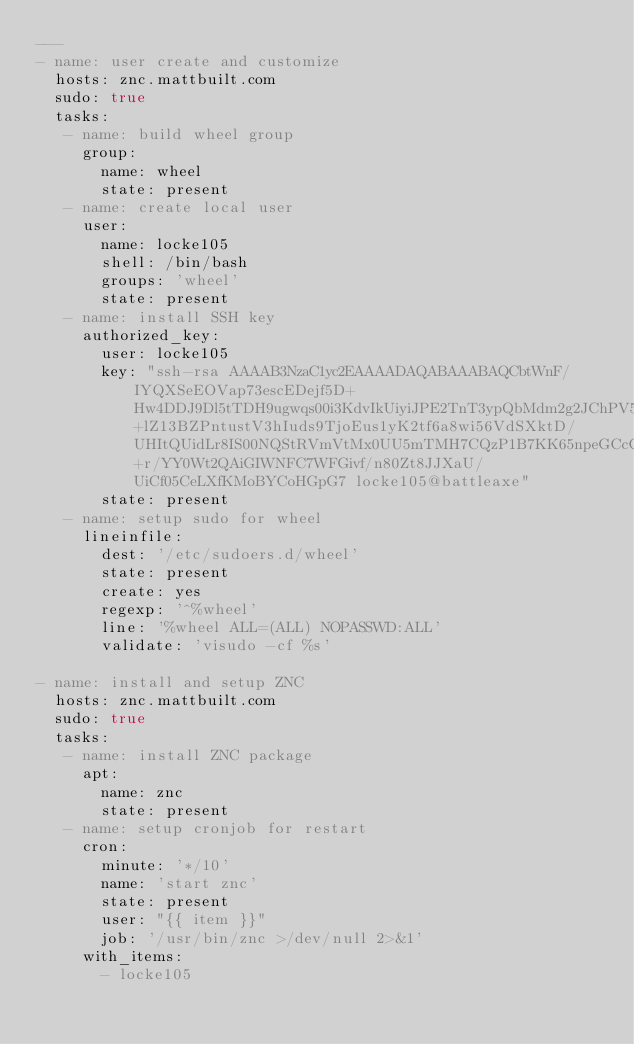<code> <loc_0><loc_0><loc_500><loc_500><_YAML_>---
- name: user create and customize
  hosts: znc.mattbuilt.com
  sudo: true
  tasks:
   - name: build wheel group
     group:
       name: wheel
       state: present
   - name: create local user
     user:
       name: locke105
       shell: /bin/bash
       groups: 'wheel'
       state: present
   - name: install SSH key
     authorized_key:
       user: locke105
       key: "ssh-rsa AAAAB3NzaC1yc2EAAAADAQABAAABAQCbtWnF/IYQXSeEOVap73escEDejf5D+Hw4DDJ9Dl5tTDH9ugwqs00i3KdvIkUiyiJPE2TnT3ypQbMdm2g2JChPV5N8P2HDvKDpfDQHBMlBYMUDtzA+lZ13BZPntustV3hIuds9TjoEus1yK2tf6a8wi56VdSXktD/UHItQUidLr8IS00NQStRVmVtMx0UU5mTMH7CQzP1B7KK65npeGCcCZOeQ7cUcAEcBOlfPjlabm1OS1bx90ZJHt9UmBQFP4TH4LauL3h7QgD73HLs1pqrEdjN+r/YY0Wt2QAiGIWNFC7WFGivf/n80Zt8JJXaU/UiCf05CeLXfKMoBYCoHGpG7 locke105@battleaxe"
       state: present
   - name: setup sudo for wheel
     lineinfile:
       dest: '/etc/sudoers.d/wheel'
       state: present
       create: yes
       regexp: '^%wheel'
       line: '%wheel ALL=(ALL) NOPASSWD:ALL'
       validate: 'visudo -cf %s'

- name: install and setup ZNC
  hosts: znc.mattbuilt.com
  sudo: true
  tasks:
   - name: install ZNC package
     apt:
       name: znc
       state: present
   - name: setup cronjob for restart
     cron:
       minute: '*/10'
       name: 'start znc'
       state: present
       user: "{{ item }}"
       job: '/usr/bin/znc >/dev/null 2>&1'
     with_items:
       - locke105
       
</code> 